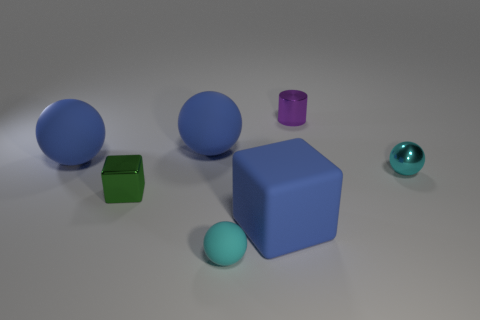Subtract all small cyan rubber spheres. How many spheres are left? 3 Add 2 rubber blocks. How many objects exist? 9 Subtract all green cubes. How many cubes are left? 1 Subtract all blue cubes. How many blue spheres are left? 2 Subtract all blocks. How many objects are left? 5 Subtract 4 balls. How many balls are left? 0 Subtract all cyan balls. Subtract all yellow blocks. How many balls are left? 2 Subtract all matte objects. Subtract all shiny blocks. How many objects are left? 2 Add 1 small green cubes. How many small green cubes are left? 2 Add 7 green rubber cubes. How many green rubber cubes exist? 7 